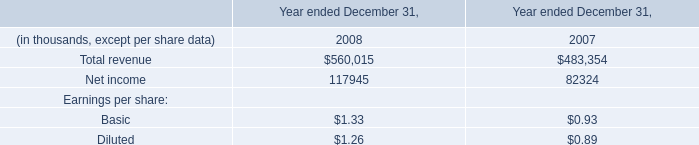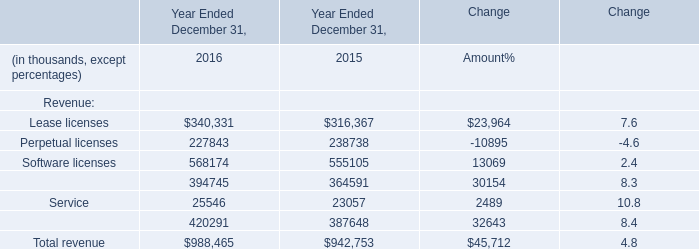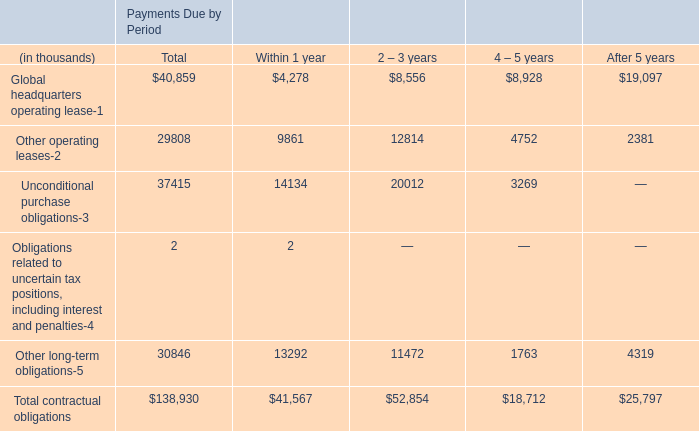what's the total amount of Net income of data 1 2007, Lease licenses of Year Ended December 31, 2016, and Maintenance and service of Year Ended December 31, 2016 ? 
Computations: ((82324.0 + 340331.0) + 420291.0)
Answer: 842946.0. 